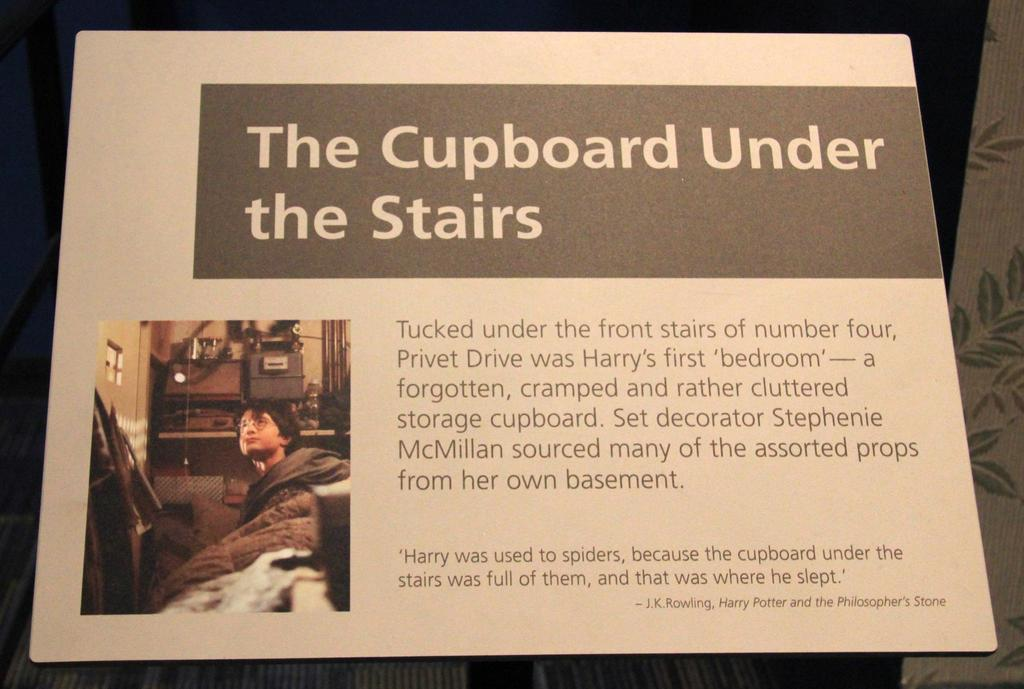Provide a one-sentence caption for the provided image. A passage that says the cupboard under the stairs. 